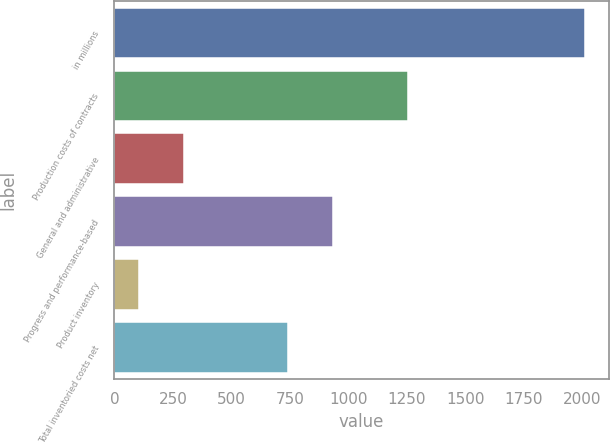<chart> <loc_0><loc_0><loc_500><loc_500><bar_chart><fcel>in millions<fcel>Production costs of contracts<fcel>General and administrative<fcel>Progress and performance-based<fcel>Product inventory<fcel>Total inventoried costs net<nl><fcel>2014<fcel>1257<fcel>296.8<fcel>932.8<fcel>106<fcel>742<nl></chart> 